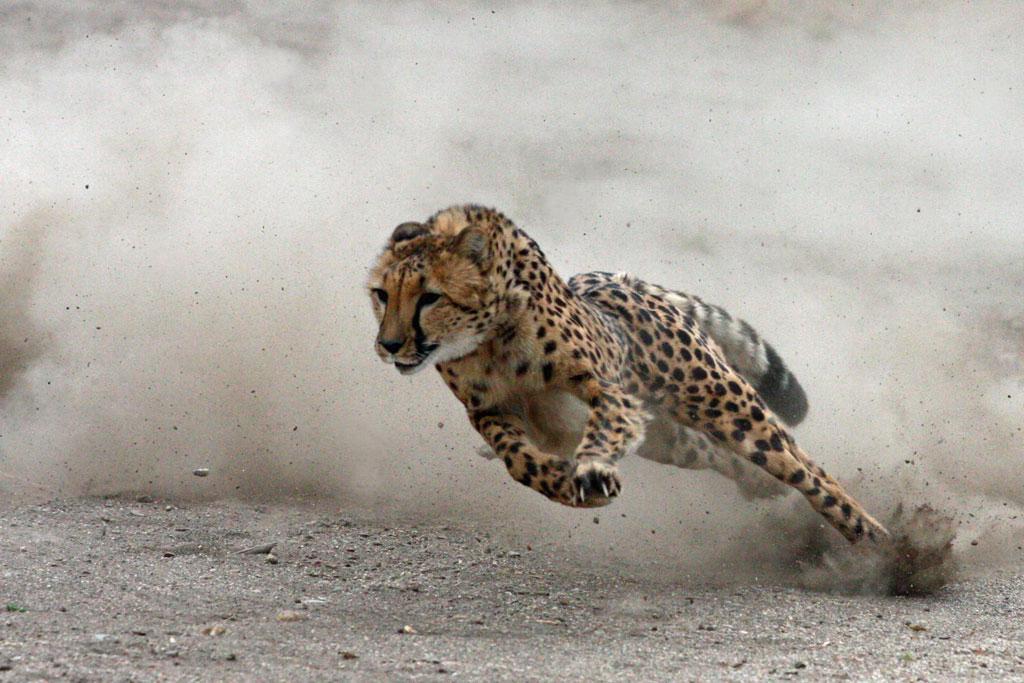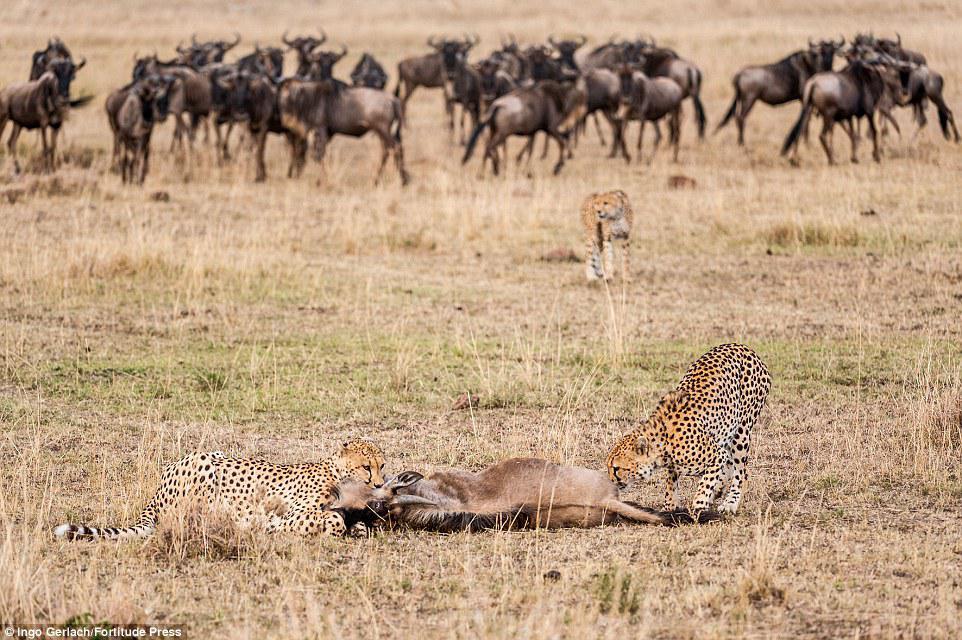The first image is the image on the left, the second image is the image on the right. Examine the images to the left and right. Is the description "There is at least one cheetah in motion." accurate? Answer yes or no. Yes. The first image is the image on the left, the second image is the image on the right. Considering the images on both sides, is "One of the big cats is running very fast and the others are eating." valid? Answer yes or no. Yes. 